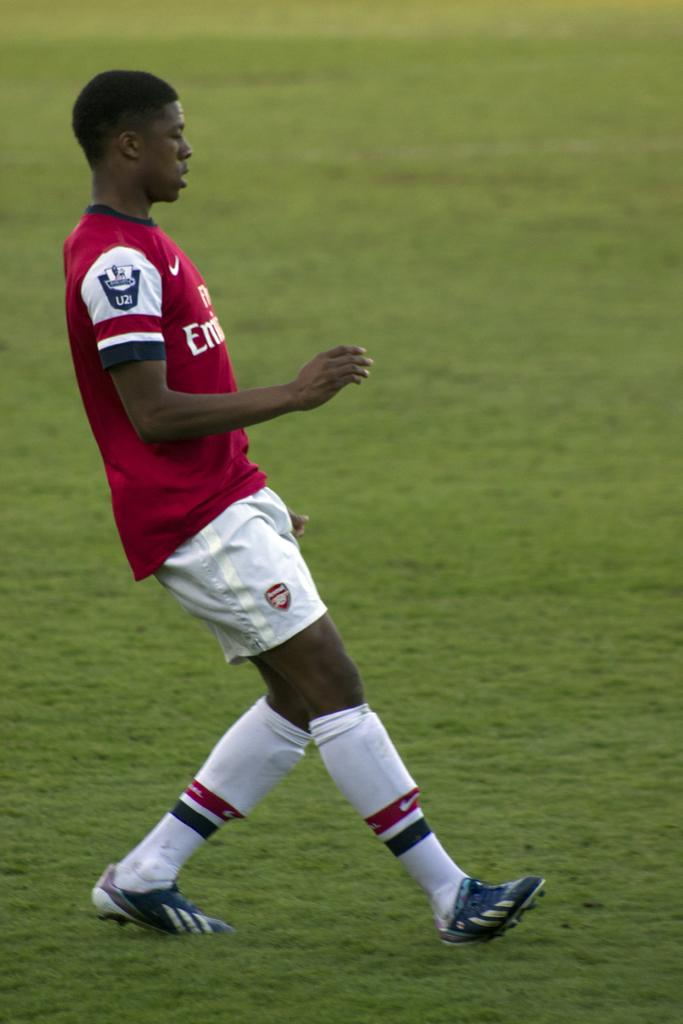Who or what is present in the image? There is a person in the image. What is the person wearing? The person is wearing a red and white dress. Where is the person located? The person is on a ground. How many pies can be seen on the ground in the image? There are no pies present in the image; it only features a person wearing a red and white dress on a ground. 